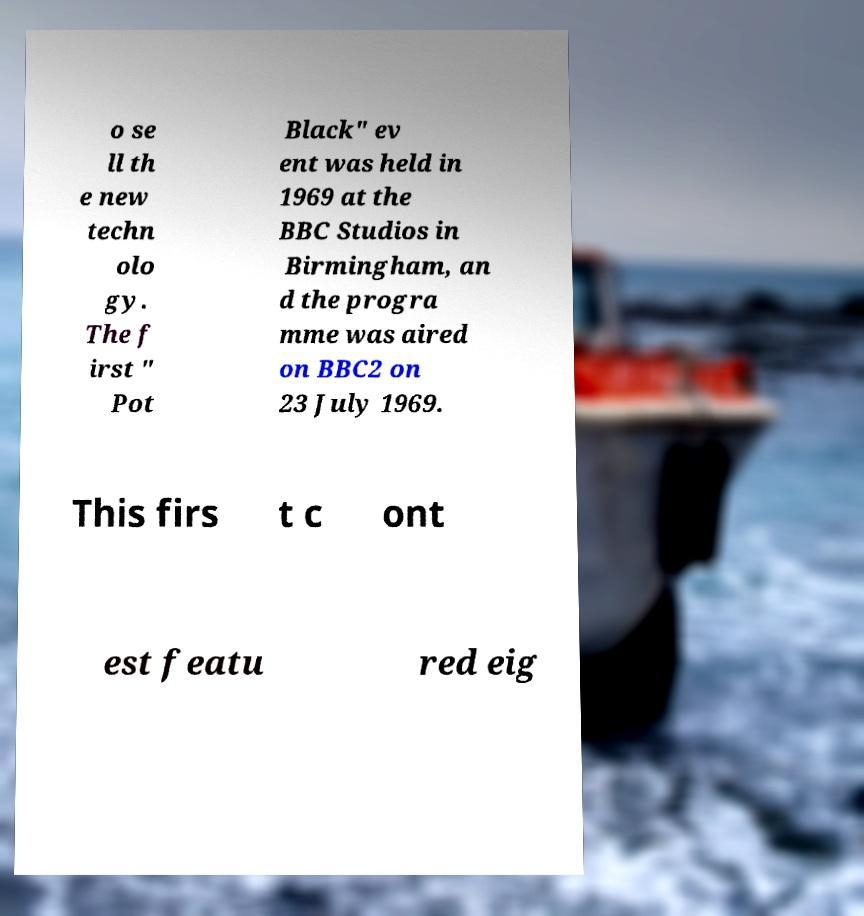Please read and relay the text visible in this image. What does it say? o se ll th e new techn olo gy. The f irst " Pot Black" ev ent was held in 1969 at the BBC Studios in Birmingham, an d the progra mme was aired on BBC2 on 23 July 1969. This firs t c ont est featu red eig 